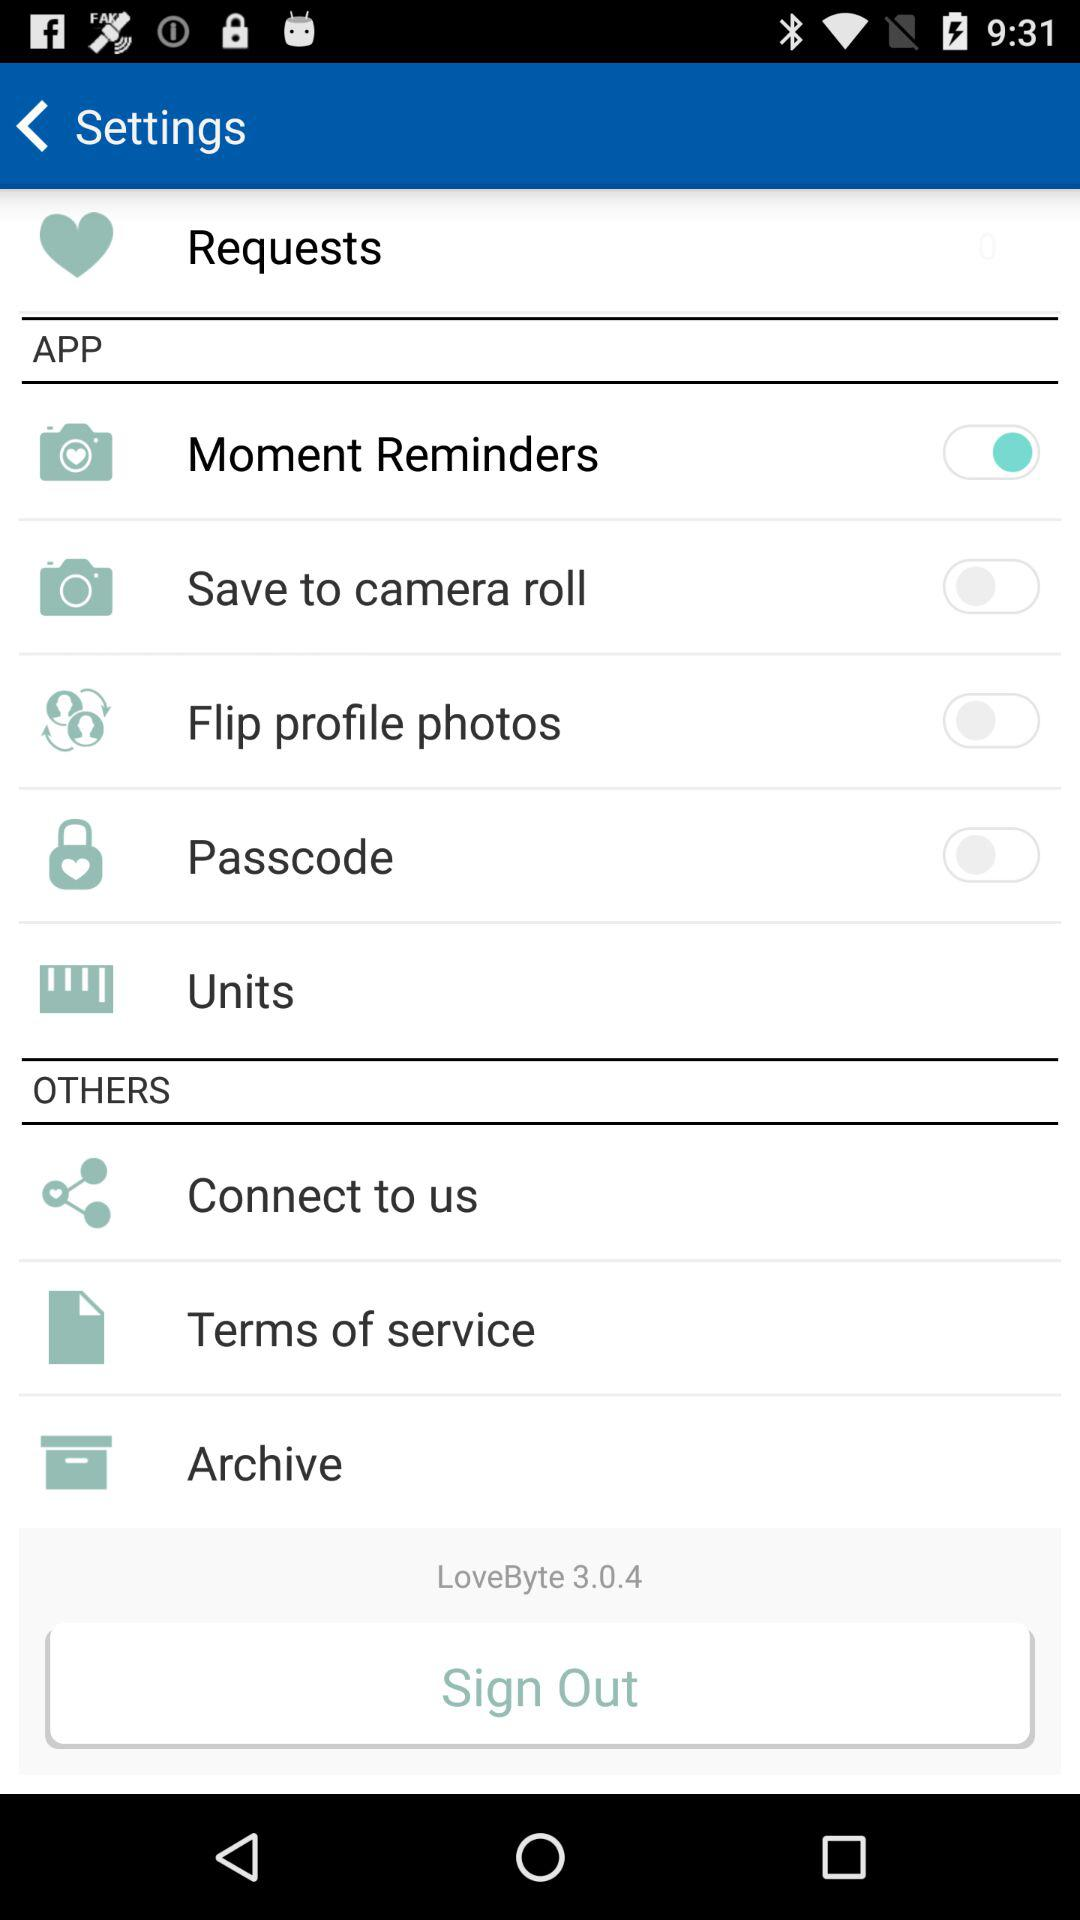What is the status of "Moment Reminders"? The status is "on". 